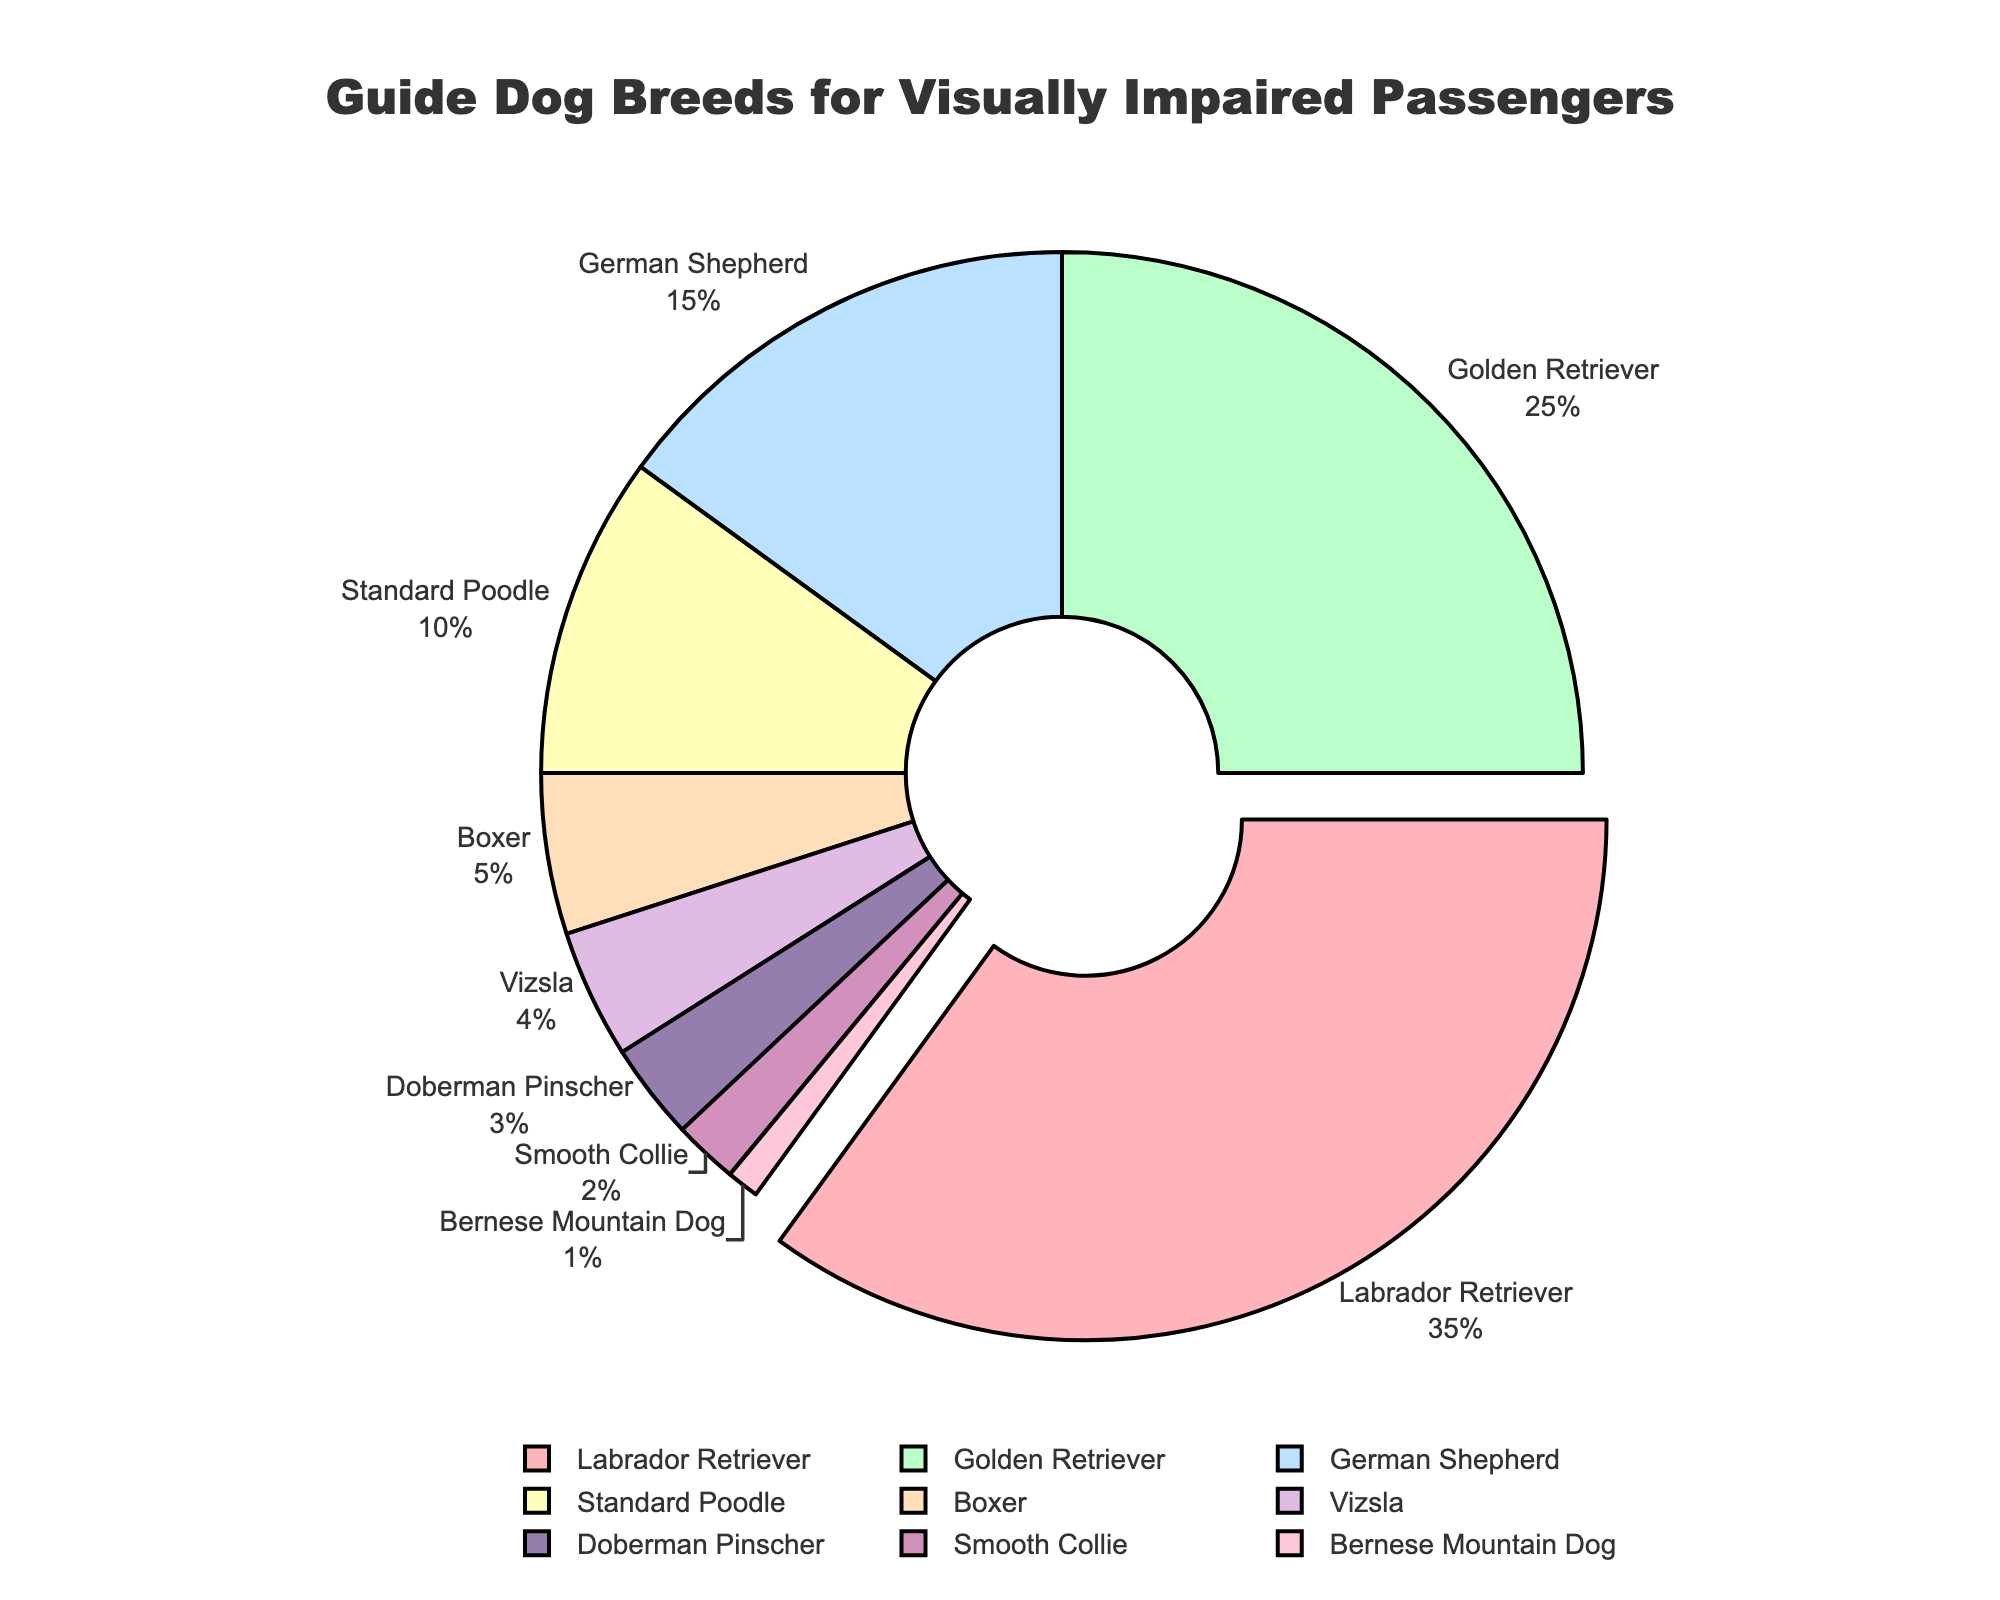Which breed has the highest percentage? The breed with the highest percentage is shown as the largest segment on the pie chart and often highlighted or pulled out slightly. In this chart, the Labrador Retriever has the highest percentage.
Answer: Labrador Retriever What is the combined percentage of Golden Retrievers and German Shepherds? To find the combined percentage, add the percentages of Golden Retrievers (25%) and German Shepherds (15%). The sum is 25 + 15 = 40%.
Answer: 40% Which breed is represented by a segment colored in green? By examining the colors assigned to each segment of the pie chart, the breed associated with the green color segment is Golden Retriever.
Answer: Golden Retriever How much larger is the percentage of Labrador Retrievers than Vizslas? To determine how much larger the percentage of Labrador Retrievers is compared to Vizslas, subtract the Vizsla percentage (4%) from the Labrador Retriever percentage (35%). The result is 35 - 4 = 31%.
Answer: 31% Are there more German Shepherds or Boxer guide dogs? By comparing the percentages, German Shepherds have 15% while Boxers have 5%. Since 15% is greater than 5%, there are more German Shepherds.
Answer: German Shepherds What is the total percentage for breeds that make up less than 10% each? Sum the percentages for Standard Poodle (10%), Boxer (5%), Vizsla (4%), Doberman Pinscher (3%), Smooth Collie (2%), and Bernese Mountain Dog (1%). The total is 10 + 5 + 4 + 3 + 2 + 1 = 25%.
Answer: 25% Which breed has the second largest segment in the chart? The second largest segment should be verified after identifying the largest segment, which is Labrador Retriever (35%). The second largest is Golden Retriever at 25%.
Answer: Golden Retriever What is the difference between the percentage of Labrador Retrievers and Golden Retrievers? Subtract the Golden Retriever percentage (25%) from the Labrador Retriever percentage (35%). The difference is 35 - 25 = 10%.
Answer: 10% Which breeds occupy the smallest combined area on the chart? Identifying the smallest individual percentages and summing them: Bernese Mountain Dog (1%) and Smooth Collie (2%), combining to 1 + 2 = 3%.
Answer: Bernese Mountain Dog and Smooth Collie 